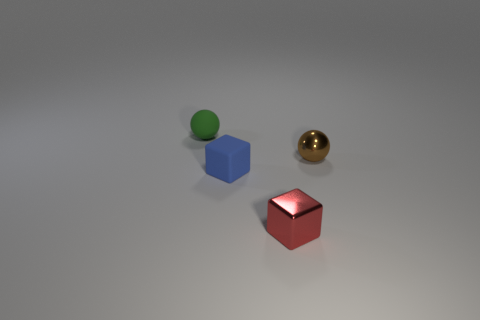Subtract all blue blocks. How many blocks are left? 1 Add 4 small cylinders. How many objects exist? 8 Subtract 1 blocks. How many blocks are left? 1 Add 4 small red metallic objects. How many small red metallic objects are left? 5 Add 2 brown things. How many brown things exist? 3 Subtract 0 red cylinders. How many objects are left? 4 Subtract all gray balls. Subtract all red cylinders. How many balls are left? 2 Subtract all blue matte cubes. Subtract all brown metal balls. How many objects are left? 2 